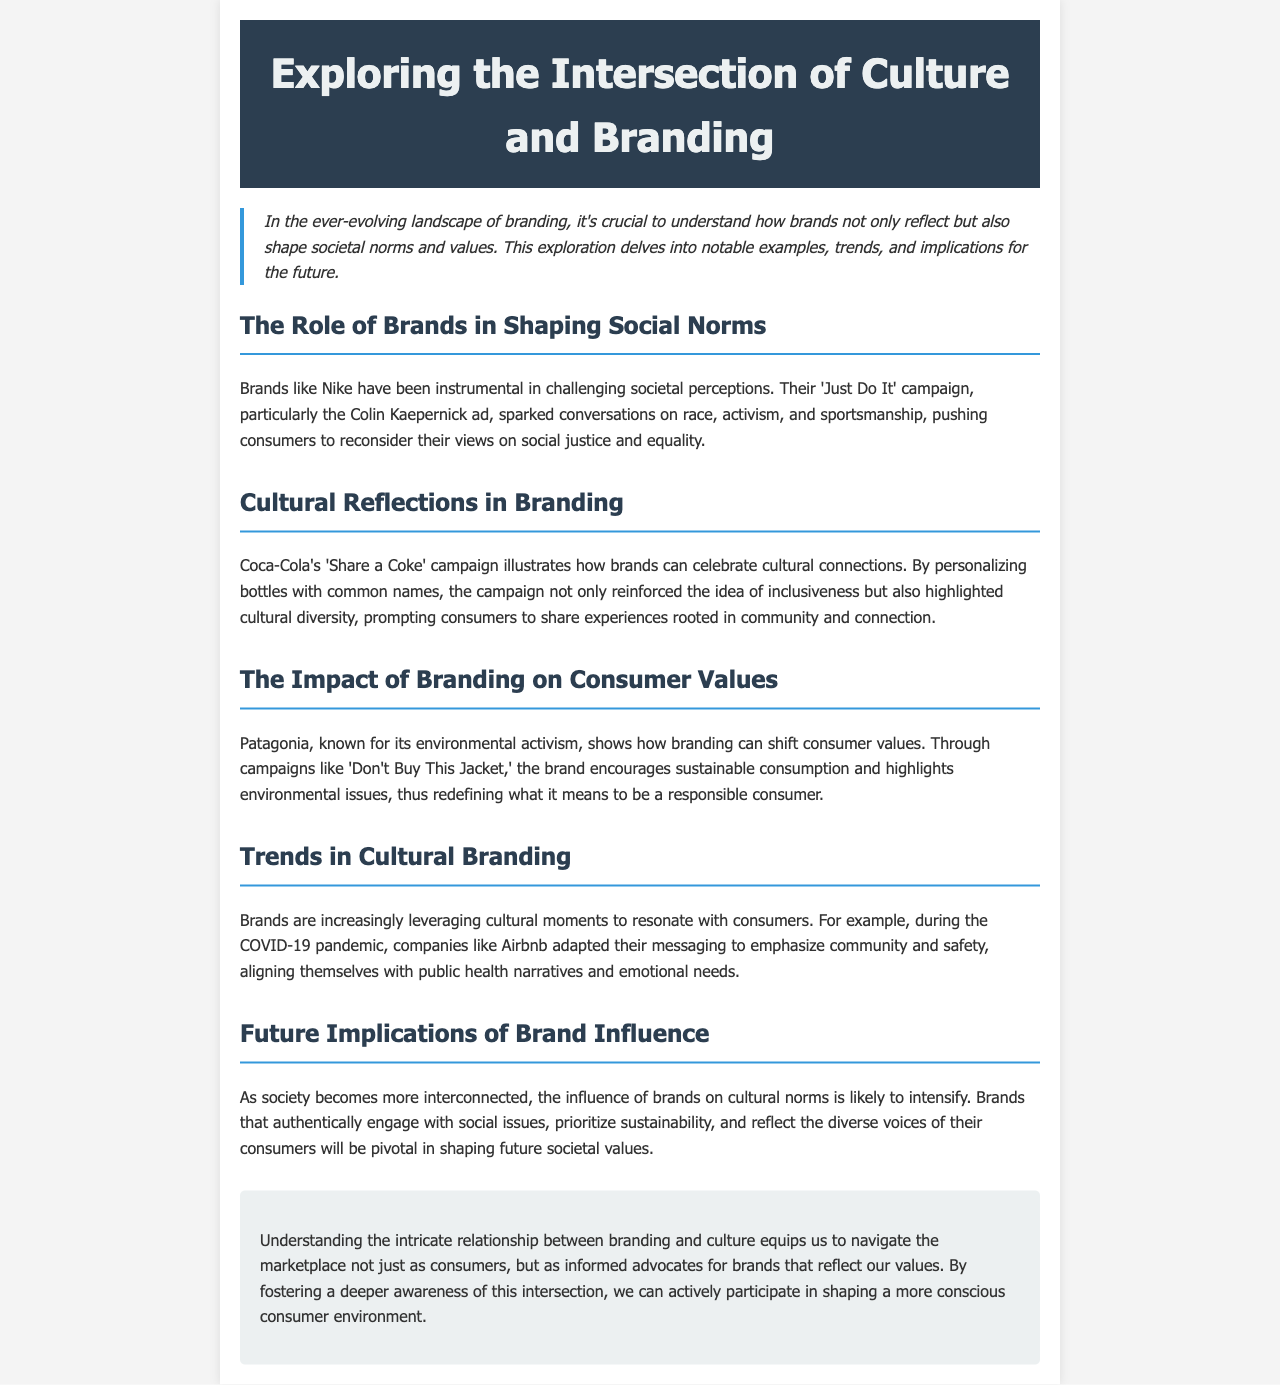What campaign did Nike use to challenge societal perceptions? Nike's 'Just Do It' campaign, particularly the Colin Kaepernick ad, sparked conversations on race, activism, and sportsmanship.
Answer: 'Just Do It' campaign What was Coca-Cola's campaign focused on? Coca-Cola's 'Share a Coke' campaign illustrates how brands can celebrate cultural connections through personalization.
Answer: 'Share a Coke' What message does Patagonia promote regarding consumer values? Patagonia encourages sustainable consumption and highlights environmental issues through campaigns like 'Don't Buy This Jacket.'
Answer: Sustainable consumption During which event did brands emphasize community and safety in their messaging? Companies like Airbnb adapted their messaging to emphasize community and safety during the COVID-19 pandemic.
Answer: COVID-19 pandemic What future shift is expected in brand influence on cultural norms? As society becomes more interconnected, the influence of brands on cultural norms is likely to intensify.
Answer: Intensify What does the conclusion suggest about the relationship between branding and culture? Understanding the relationship equips consumers to navigate the marketplace as informed advocates for brands that reflect their values.
Answer: Informed advocates 